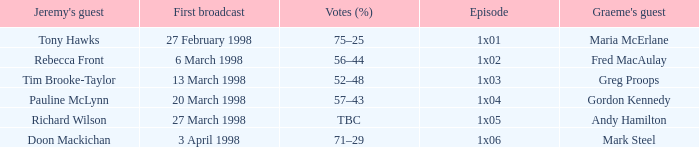What is First Broadcast, when Jeremy's Guest is "Tim Brooke-Taylor"? 13 March 1998. 